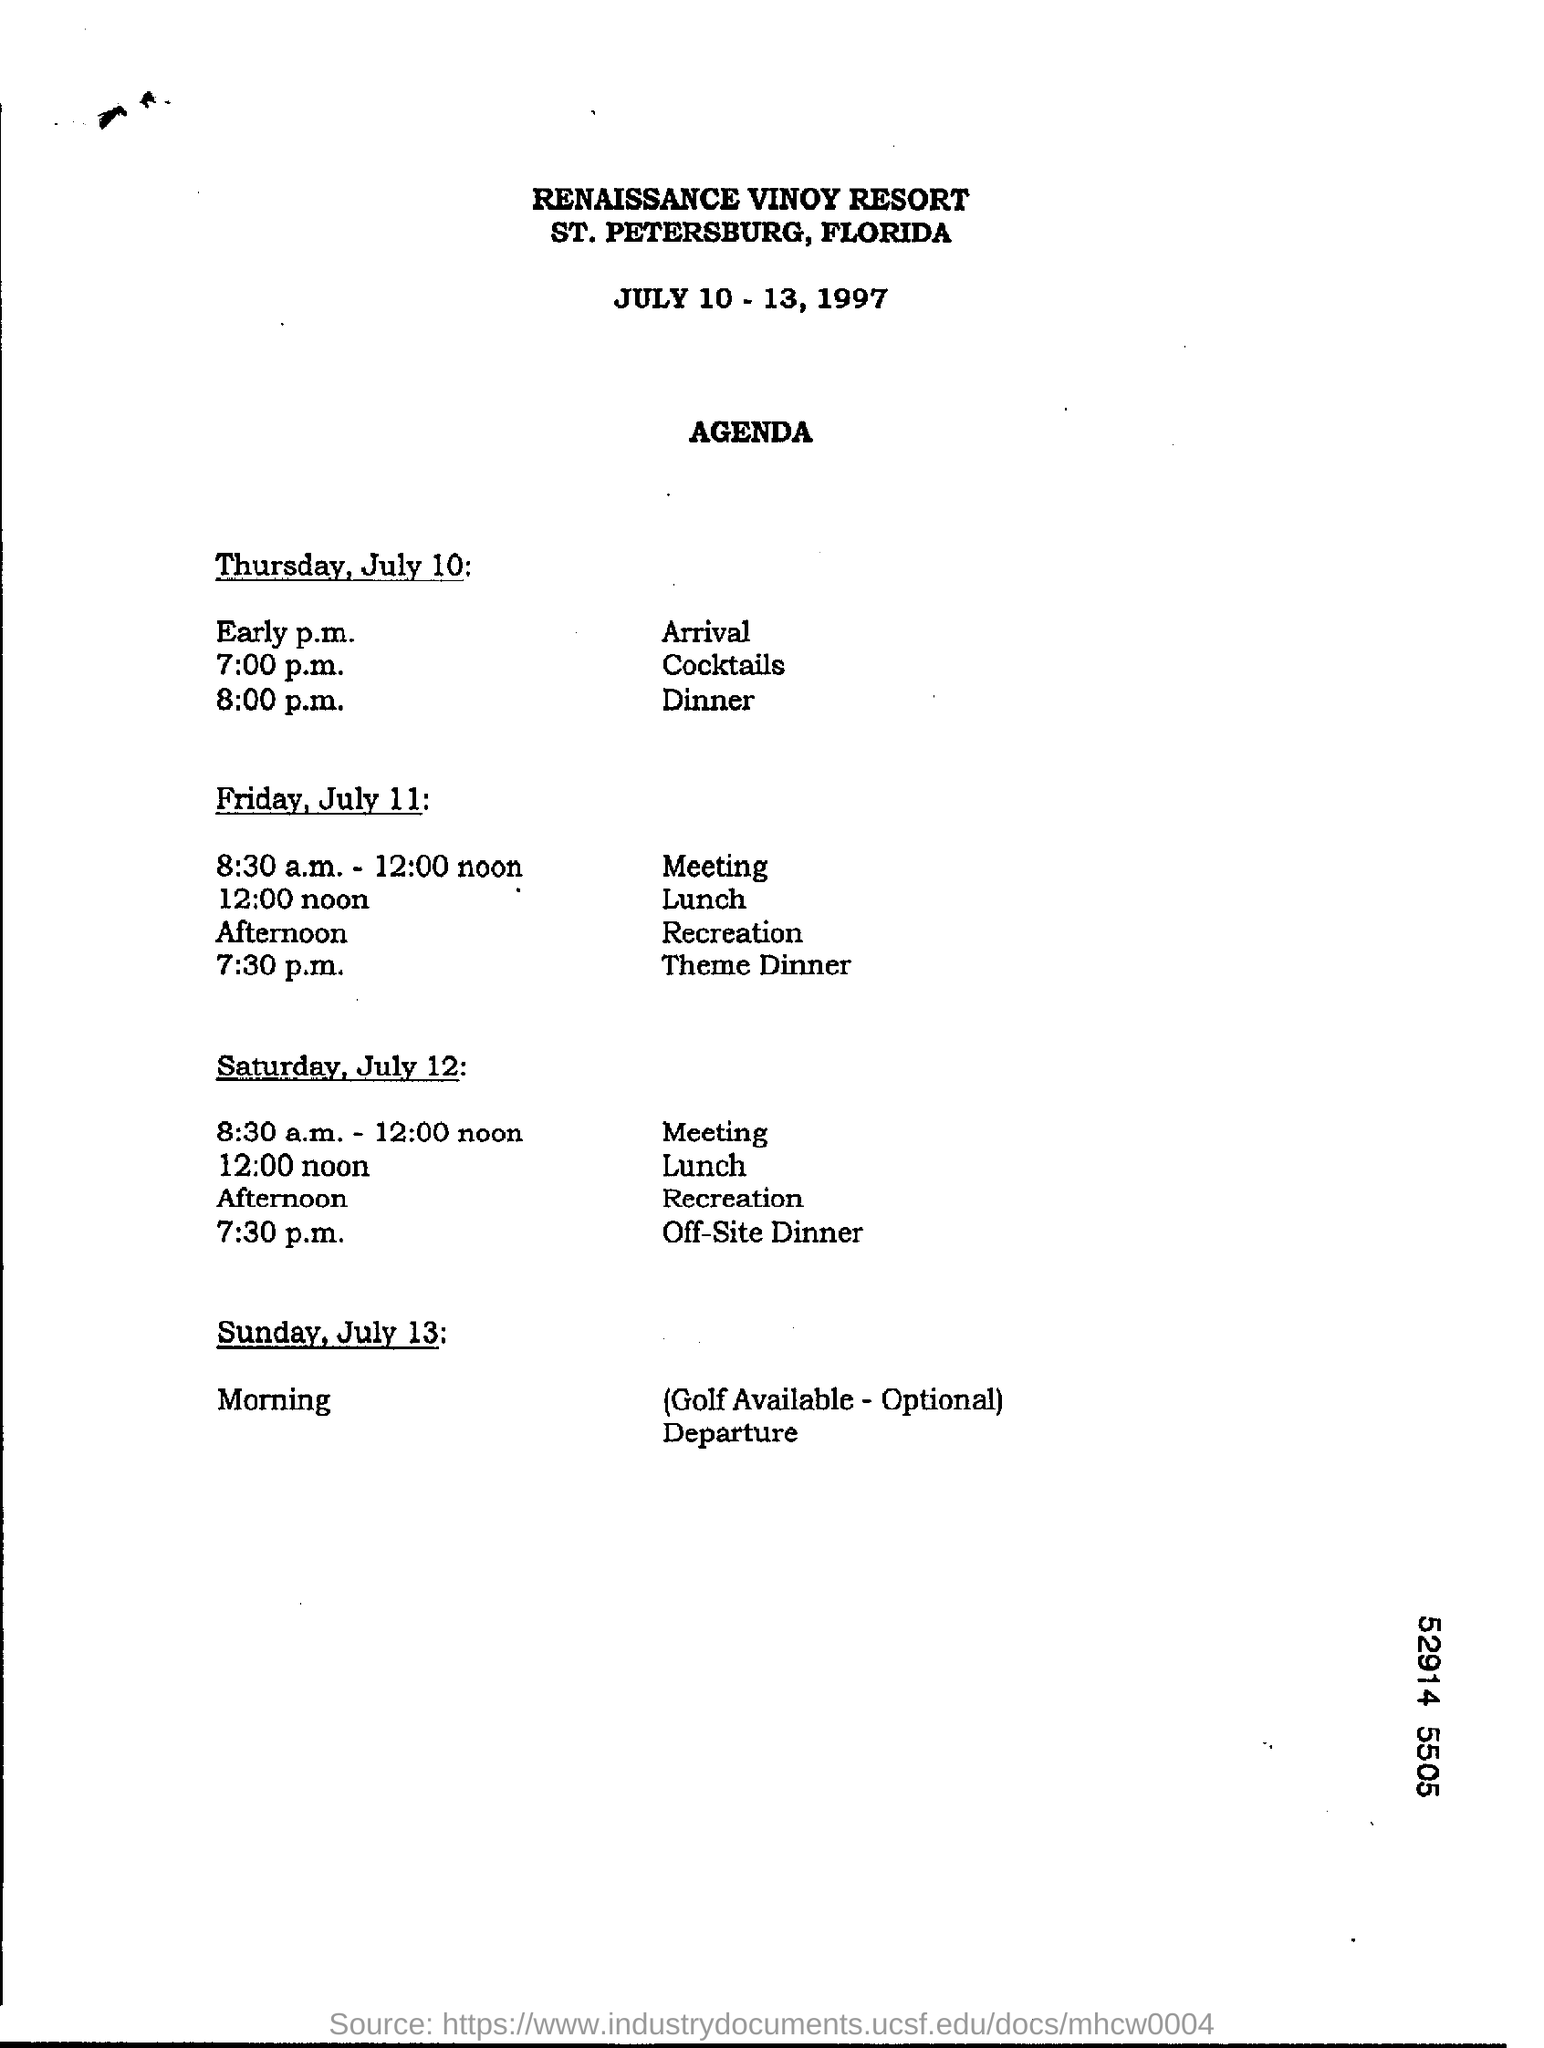Which Resort's Agenda is given here?
Keep it short and to the point. RENAISSANCE VINOY RESORT. What is the Lunchtime on Friday , July 11?
Offer a terse response. 12.00 noon. At what time, the meeting  has been scheduled on Saturday, July 12?
Offer a very short reply. 8.30 a.m. - 12.00 noon. On which date, the theme dinner is scheduled at 7.30 p.m.?
Your answer should be very brief. Friday, July 11. At what time, off-site Dinner has been scheduled on saturday, July 12?
Make the answer very short. 7.30 p.m. 